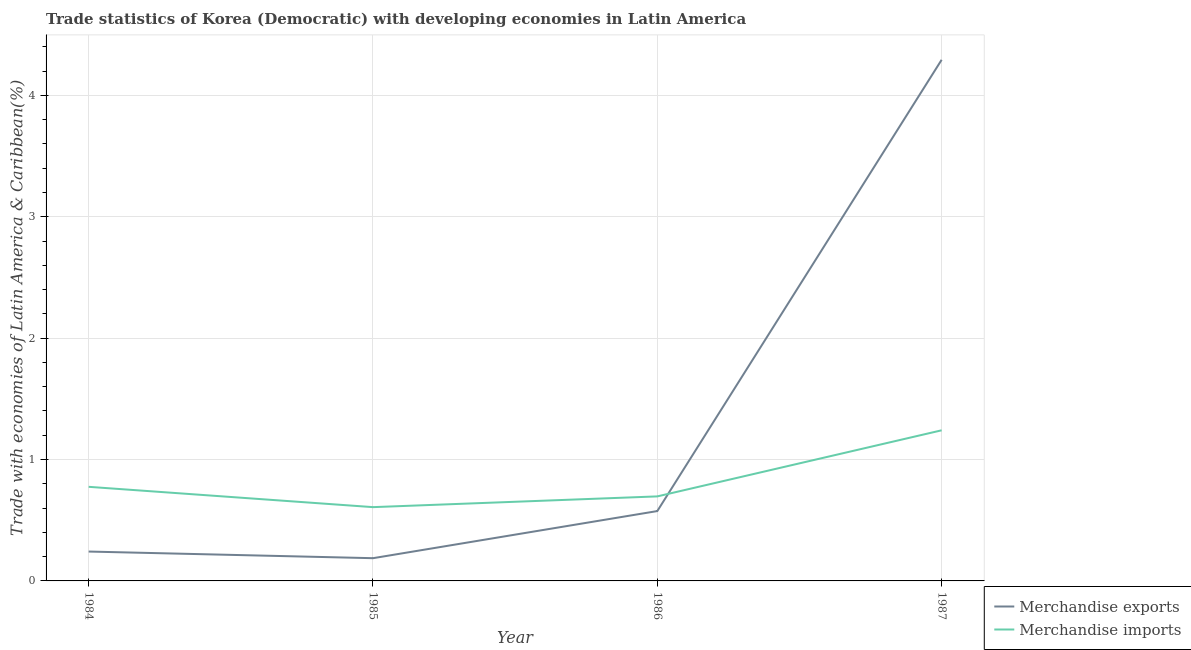What is the merchandise imports in 1987?
Offer a terse response. 1.24. Across all years, what is the maximum merchandise exports?
Your answer should be compact. 4.29. Across all years, what is the minimum merchandise exports?
Make the answer very short. 0.19. In which year was the merchandise exports maximum?
Offer a very short reply. 1987. In which year was the merchandise imports minimum?
Keep it short and to the point. 1985. What is the total merchandise imports in the graph?
Ensure brevity in your answer.  3.32. What is the difference between the merchandise exports in 1984 and that in 1986?
Your answer should be compact. -0.33. What is the difference between the merchandise imports in 1986 and the merchandise exports in 1984?
Keep it short and to the point. 0.45. What is the average merchandise exports per year?
Your response must be concise. 1.32. In the year 1986, what is the difference between the merchandise exports and merchandise imports?
Ensure brevity in your answer.  -0.12. What is the ratio of the merchandise imports in 1986 to that in 1987?
Keep it short and to the point. 0.56. What is the difference between the highest and the second highest merchandise imports?
Offer a very short reply. 0.47. What is the difference between the highest and the lowest merchandise exports?
Give a very brief answer. 4.11. In how many years, is the merchandise exports greater than the average merchandise exports taken over all years?
Offer a terse response. 1. Is the sum of the merchandise exports in 1984 and 1986 greater than the maximum merchandise imports across all years?
Provide a succinct answer. No. Does the merchandise imports monotonically increase over the years?
Provide a short and direct response. No. Is the merchandise exports strictly greater than the merchandise imports over the years?
Make the answer very short. No. Is the merchandise imports strictly less than the merchandise exports over the years?
Ensure brevity in your answer.  No. What is the difference between two consecutive major ticks on the Y-axis?
Provide a short and direct response. 1. Does the graph contain grids?
Ensure brevity in your answer.  Yes. Where does the legend appear in the graph?
Ensure brevity in your answer.  Bottom right. What is the title of the graph?
Give a very brief answer. Trade statistics of Korea (Democratic) with developing economies in Latin America. Does "Techinal cooperation" appear as one of the legend labels in the graph?
Provide a short and direct response. No. What is the label or title of the X-axis?
Provide a succinct answer. Year. What is the label or title of the Y-axis?
Keep it short and to the point. Trade with economies of Latin America & Caribbean(%). What is the Trade with economies of Latin America & Caribbean(%) of Merchandise exports in 1984?
Give a very brief answer. 0.24. What is the Trade with economies of Latin America & Caribbean(%) in Merchandise imports in 1984?
Provide a succinct answer. 0.78. What is the Trade with economies of Latin America & Caribbean(%) in Merchandise exports in 1985?
Make the answer very short. 0.19. What is the Trade with economies of Latin America & Caribbean(%) in Merchandise imports in 1985?
Provide a succinct answer. 0.61. What is the Trade with economies of Latin America & Caribbean(%) in Merchandise exports in 1986?
Your answer should be very brief. 0.58. What is the Trade with economies of Latin America & Caribbean(%) of Merchandise imports in 1986?
Your answer should be compact. 0.7. What is the Trade with economies of Latin America & Caribbean(%) in Merchandise exports in 1987?
Your response must be concise. 4.29. What is the Trade with economies of Latin America & Caribbean(%) of Merchandise imports in 1987?
Offer a terse response. 1.24. Across all years, what is the maximum Trade with economies of Latin America & Caribbean(%) of Merchandise exports?
Offer a terse response. 4.29. Across all years, what is the maximum Trade with economies of Latin America & Caribbean(%) of Merchandise imports?
Offer a terse response. 1.24. Across all years, what is the minimum Trade with economies of Latin America & Caribbean(%) in Merchandise exports?
Ensure brevity in your answer.  0.19. Across all years, what is the minimum Trade with economies of Latin America & Caribbean(%) of Merchandise imports?
Give a very brief answer. 0.61. What is the total Trade with economies of Latin America & Caribbean(%) of Merchandise exports in the graph?
Your answer should be very brief. 5.3. What is the total Trade with economies of Latin America & Caribbean(%) in Merchandise imports in the graph?
Provide a succinct answer. 3.32. What is the difference between the Trade with economies of Latin America & Caribbean(%) in Merchandise exports in 1984 and that in 1985?
Your response must be concise. 0.05. What is the difference between the Trade with economies of Latin America & Caribbean(%) in Merchandise imports in 1984 and that in 1985?
Your response must be concise. 0.17. What is the difference between the Trade with economies of Latin America & Caribbean(%) in Merchandise exports in 1984 and that in 1986?
Give a very brief answer. -0.33. What is the difference between the Trade with economies of Latin America & Caribbean(%) of Merchandise imports in 1984 and that in 1986?
Keep it short and to the point. 0.08. What is the difference between the Trade with economies of Latin America & Caribbean(%) of Merchandise exports in 1984 and that in 1987?
Provide a succinct answer. -4.05. What is the difference between the Trade with economies of Latin America & Caribbean(%) in Merchandise imports in 1984 and that in 1987?
Provide a short and direct response. -0.47. What is the difference between the Trade with economies of Latin America & Caribbean(%) of Merchandise exports in 1985 and that in 1986?
Your answer should be very brief. -0.39. What is the difference between the Trade with economies of Latin America & Caribbean(%) in Merchandise imports in 1985 and that in 1986?
Give a very brief answer. -0.09. What is the difference between the Trade with economies of Latin America & Caribbean(%) of Merchandise exports in 1985 and that in 1987?
Give a very brief answer. -4.11. What is the difference between the Trade with economies of Latin America & Caribbean(%) in Merchandise imports in 1985 and that in 1987?
Give a very brief answer. -0.63. What is the difference between the Trade with economies of Latin America & Caribbean(%) of Merchandise exports in 1986 and that in 1987?
Your answer should be compact. -3.72. What is the difference between the Trade with economies of Latin America & Caribbean(%) in Merchandise imports in 1986 and that in 1987?
Your answer should be very brief. -0.54. What is the difference between the Trade with economies of Latin America & Caribbean(%) in Merchandise exports in 1984 and the Trade with economies of Latin America & Caribbean(%) in Merchandise imports in 1985?
Make the answer very short. -0.37. What is the difference between the Trade with economies of Latin America & Caribbean(%) in Merchandise exports in 1984 and the Trade with economies of Latin America & Caribbean(%) in Merchandise imports in 1986?
Ensure brevity in your answer.  -0.45. What is the difference between the Trade with economies of Latin America & Caribbean(%) of Merchandise exports in 1984 and the Trade with economies of Latin America & Caribbean(%) of Merchandise imports in 1987?
Offer a very short reply. -1. What is the difference between the Trade with economies of Latin America & Caribbean(%) of Merchandise exports in 1985 and the Trade with economies of Latin America & Caribbean(%) of Merchandise imports in 1986?
Give a very brief answer. -0.51. What is the difference between the Trade with economies of Latin America & Caribbean(%) in Merchandise exports in 1985 and the Trade with economies of Latin America & Caribbean(%) in Merchandise imports in 1987?
Offer a terse response. -1.05. What is the difference between the Trade with economies of Latin America & Caribbean(%) of Merchandise exports in 1986 and the Trade with economies of Latin America & Caribbean(%) of Merchandise imports in 1987?
Your answer should be very brief. -0.67. What is the average Trade with economies of Latin America & Caribbean(%) of Merchandise exports per year?
Give a very brief answer. 1.32. What is the average Trade with economies of Latin America & Caribbean(%) in Merchandise imports per year?
Your answer should be compact. 0.83. In the year 1984, what is the difference between the Trade with economies of Latin America & Caribbean(%) in Merchandise exports and Trade with economies of Latin America & Caribbean(%) in Merchandise imports?
Provide a succinct answer. -0.53. In the year 1985, what is the difference between the Trade with economies of Latin America & Caribbean(%) in Merchandise exports and Trade with economies of Latin America & Caribbean(%) in Merchandise imports?
Give a very brief answer. -0.42. In the year 1986, what is the difference between the Trade with economies of Latin America & Caribbean(%) in Merchandise exports and Trade with economies of Latin America & Caribbean(%) in Merchandise imports?
Ensure brevity in your answer.  -0.12. In the year 1987, what is the difference between the Trade with economies of Latin America & Caribbean(%) in Merchandise exports and Trade with economies of Latin America & Caribbean(%) in Merchandise imports?
Provide a short and direct response. 3.05. What is the ratio of the Trade with economies of Latin America & Caribbean(%) of Merchandise exports in 1984 to that in 1985?
Offer a very short reply. 1.29. What is the ratio of the Trade with economies of Latin America & Caribbean(%) of Merchandise imports in 1984 to that in 1985?
Your answer should be compact. 1.28. What is the ratio of the Trade with economies of Latin America & Caribbean(%) in Merchandise exports in 1984 to that in 1986?
Keep it short and to the point. 0.42. What is the ratio of the Trade with economies of Latin America & Caribbean(%) of Merchandise imports in 1984 to that in 1986?
Your answer should be very brief. 1.11. What is the ratio of the Trade with economies of Latin America & Caribbean(%) in Merchandise exports in 1984 to that in 1987?
Your answer should be compact. 0.06. What is the ratio of the Trade with economies of Latin America & Caribbean(%) of Merchandise imports in 1984 to that in 1987?
Offer a terse response. 0.62. What is the ratio of the Trade with economies of Latin America & Caribbean(%) in Merchandise exports in 1985 to that in 1986?
Your answer should be very brief. 0.33. What is the ratio of the Trade with economies of Latin America & Caribbean(%) of Merchandise imports in 1985 to that in 1986?
Give a very brief answer. 0.87. What is the ratio of the Trade with economies of Latin America & Caribbean(%) in Merchandise exports in 1985 to that in 1987?
Your response must be concise. 0.04. What is the ratio of the Trade with economies of Latin America & Caribbean(%) of Merchandise imports in 1985 to that in 1987?
Offer a very short reply. 0.49. What is the ratio of the Trade with economies of Latin America & Caribbean(%) in Merchandise exports in 1986 to that in 1987?
Give a very brief answer. 0.13. What is the ratio of the Trade with economies of Latin America & Caribbean(%) of Merchandise imports in 1986 to that in 1987?
Give a very brief answer. 0.56. What is the difference between the highest and the second highest Trade with economies of Latin America & Caribbean(%) of Merchandise exports?
Your response must be concise. 3.72. What is the difference between the highest and the second highest Trade with economies of Latin America & Caribbean(%) of Merchandise imports?
Give a very brief answer. 0.47. What is the difference between the highest and the lowest Trade with economies of Latin America & Caribbean(%) of Merchandise exports?
Give a very brief answer. 4.11. What is the difference between the highest and the lowest Trade with economies of Latin America & Caribbean(%) of Merchandise imports?
Keep it short and to the point. 0.63. 